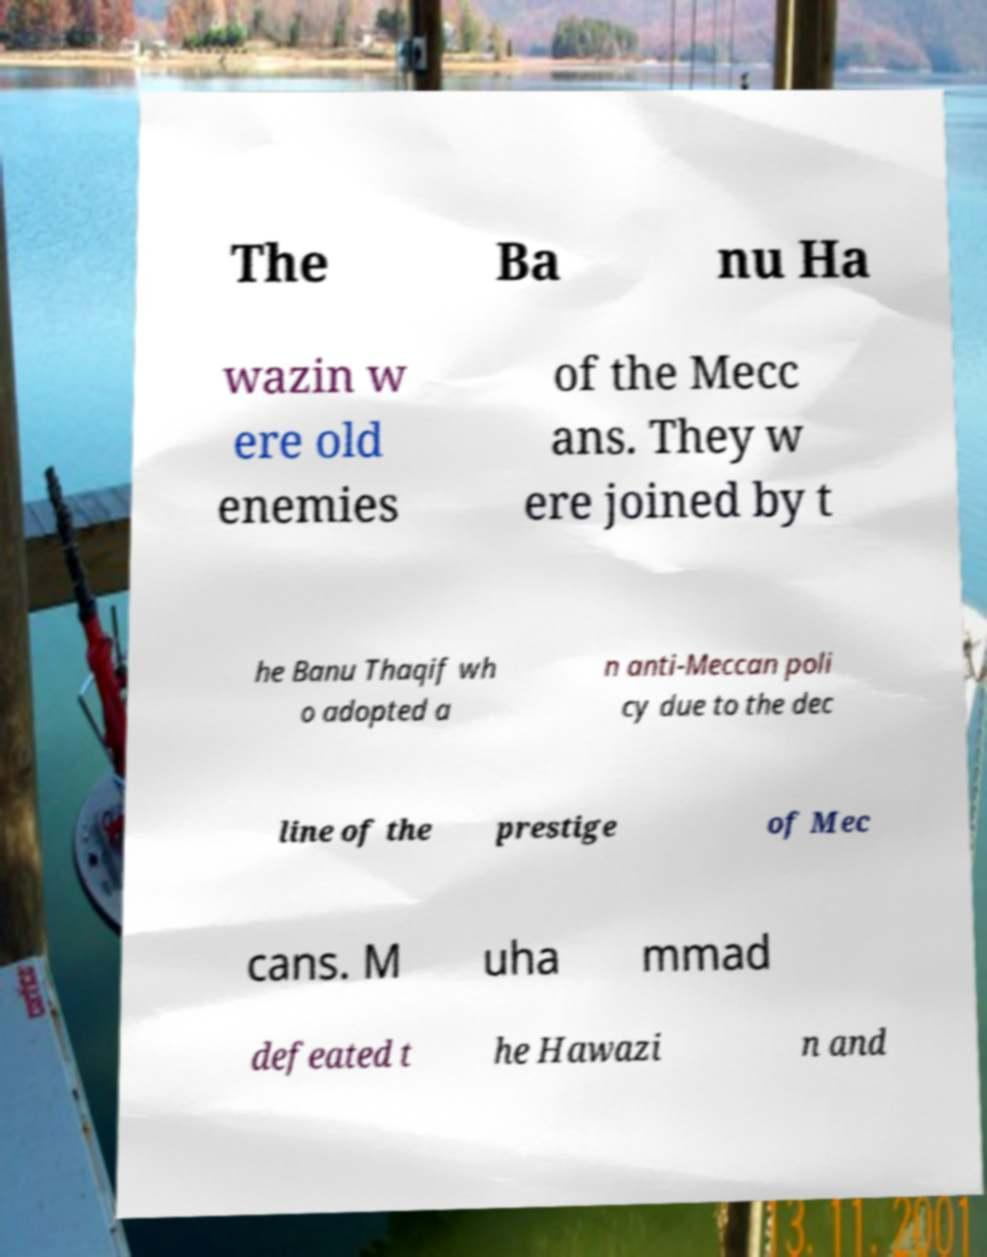Could you assist in decoding the text presented in this image and type it out clearly? The Ba nu Ha wazin w ere old enemies of the Mecc ans. They w ere joined by t he Banu Thaqif wh o adopted a n anti-Meccan poli cy due to the dec line of the prestige of Mec cans. M uha mmad defeated t he Hawazi n and 